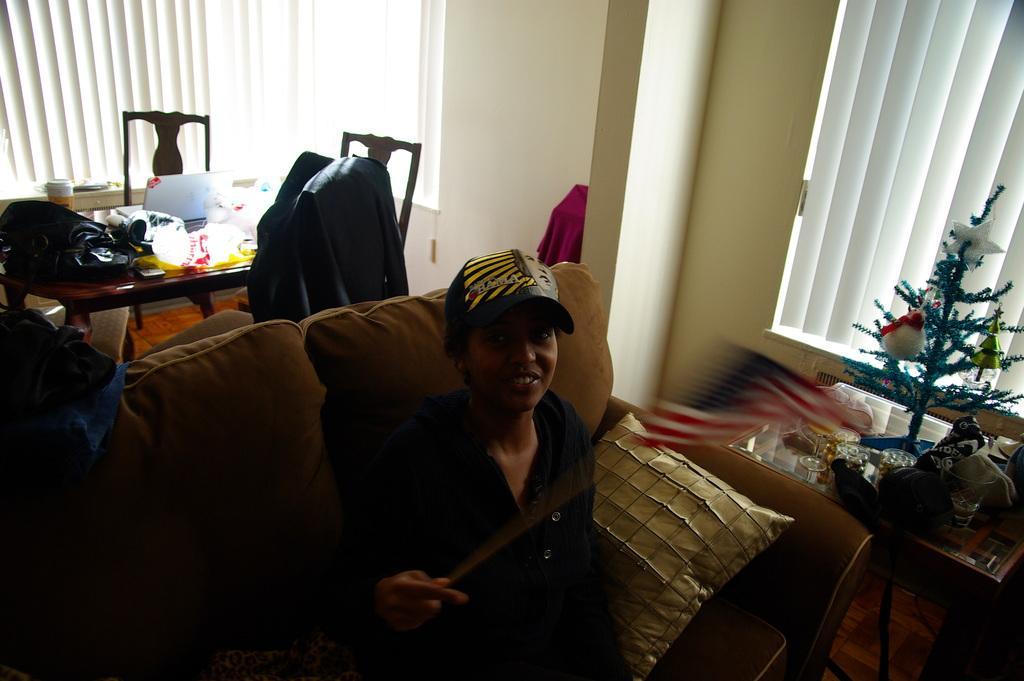Could you give a brief overview of what you see in this image? This is a picture taken in a room, the person is sitting on a sofa beside the person there is a cushion. Behind the person there is a table on there are some items, laptop, bag and chairs. To the right side of the woman there is other table on the table there are glasses, cloth and Christmas tree. 